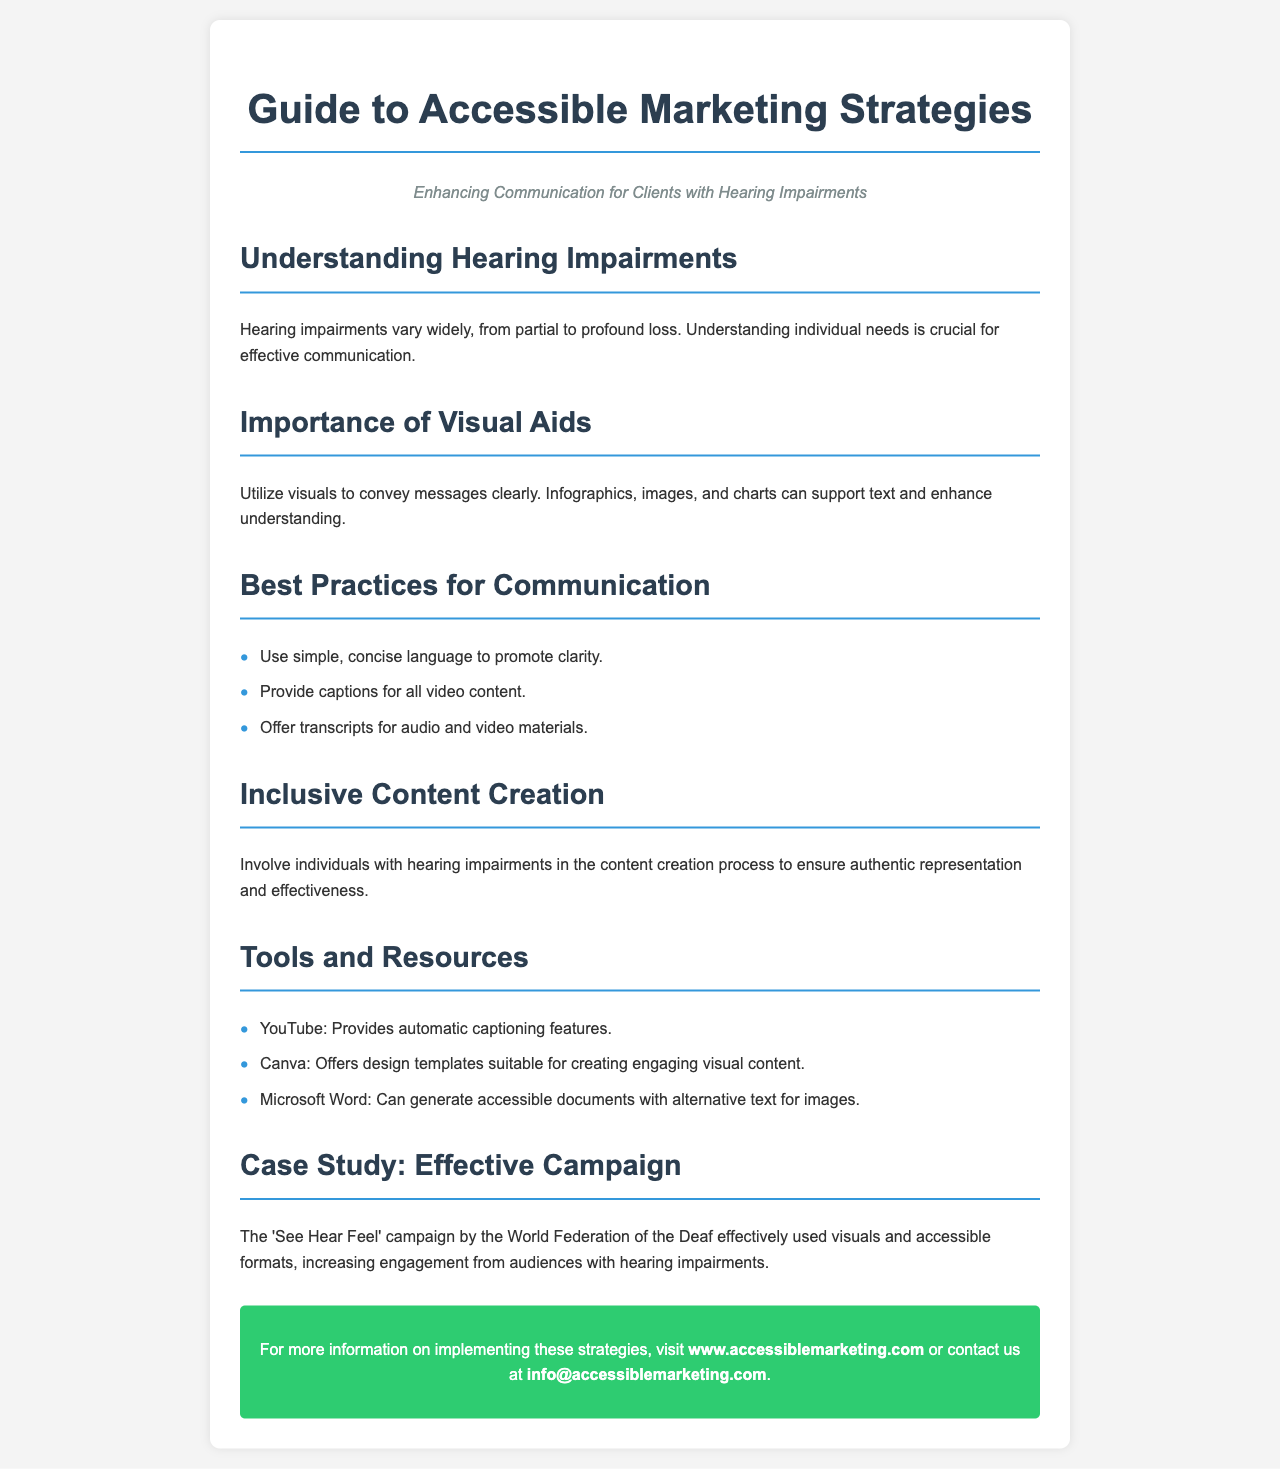What is the title of the brochure? The title is prominently displayed at the top of the document.
Answer: Guide to Accessible Marketing Strategies What is the subtitle of the brochure? The subtitle provides additional context about the document's focus.
Answer: Enhancing Communication for Clients with Hearing Impairments What is one of the best practices for communication mentioned? This information is found in the section outlining best practices.
Answer: Provide captions for all video content Which campaign is used as a case study? The document references a specific campaign to illustrate effective strategies.
Answer: See Hear Feel What tool offers design templates for visual content? This information is listed under the tools and resources section.
Answer: Canva How many best practices for communication are listed? The document presents a clear list of best practices in the specified section.
Answer: Three What should individuals with hearing impairments be involved in? This information emphasizes the importance of representation in the content creation process.
Answer: Content creation What does Microsoft Word generate that aids accessibility? The document highlights a specific feature of Microsoft Word related to document accessibility.
Answer: Accessible documents with alternative text 